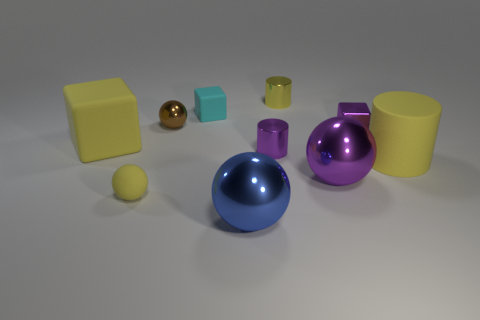Subtract all cylinders. How many objects are left? 7 Add 2 yellow matte spheres. How many yellow matte spheres exist? 3 Subtract 0 blue cylinders. How many objects are left? 10 Subtract all large purple things. Subtract all tiny brown things. How many objects are left? 8 Add 6 large yellow rubber cubes. How many large yellow rubber cubes are left? 7 